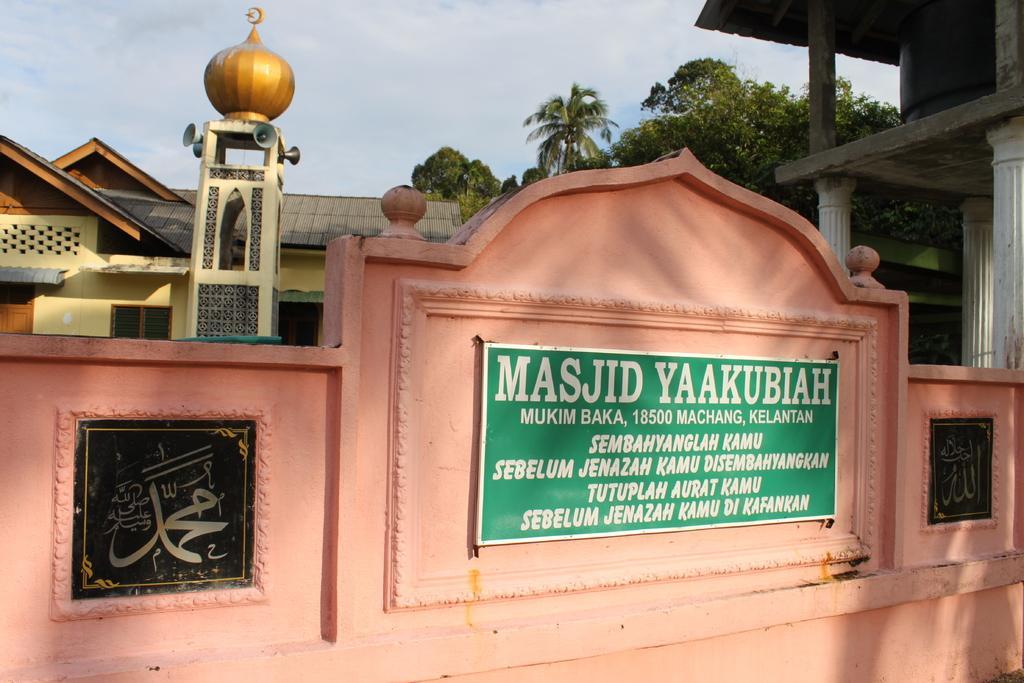Can you describe this image briefly? In the center of the image there is a mosque. There is a nameplate with some text on it. In the background of the image there is sky, trees and buildings. 